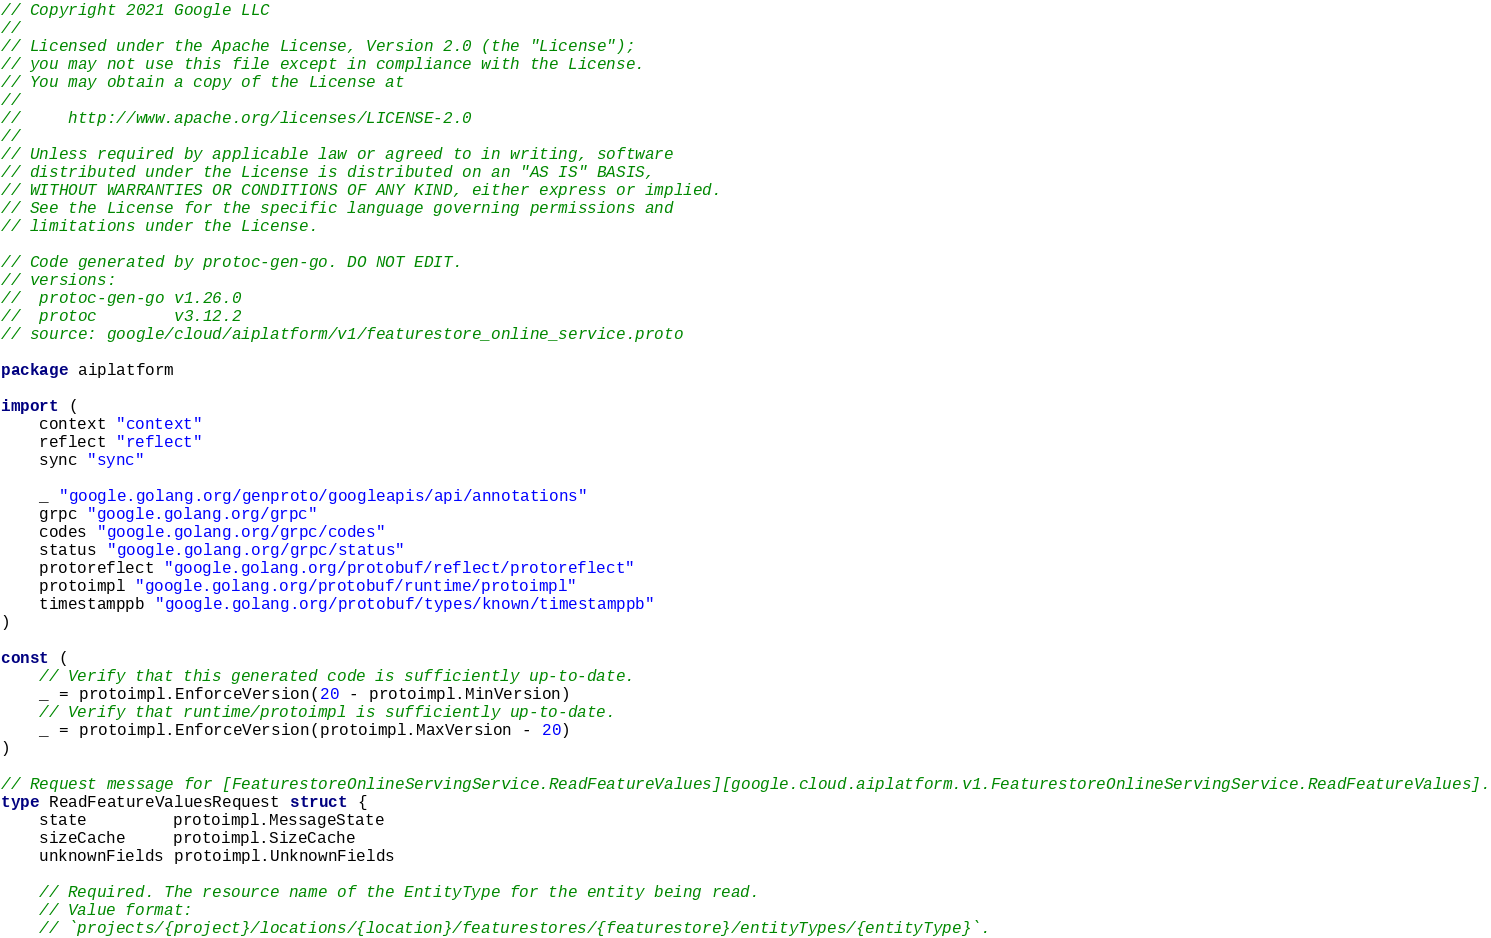Convert code to text. <code><loc_0><loc_0><loc_500><loc_500><_Go_>// Copyright 2021 Google LLC
//
// Licensed under the Apache License, Version 2.0 (the "License");
// you may not use this file except in compliance with the License.
// You may obtain a copy of the License at
//
//     http://www.apache.org/licenses/LICENSE-2.0
//
// Unless required by applicable law or agreed to in writing, software
// distributed under the License is distributed on an "AS IS" BASIS,
// WITHOUT WARRANTIES OR CONDITIONS OF ANY KIND, either express or implied.
// See the License for the specific language governing permissions and
// limitations under the License.

// Code generated by protoc-gen-go. DO NOT EDIT.
// versions:
// 	protoc-gen-go v1.26.0
// 	protoc        v3.12.2
// source: google/cloud/aiplatform/v1/featurestore_online_service.proto

package aiplatform

import (
	context "context"
	reflect "reflect"
	sync "sync"

	_ "google.golang.org/genproto/googleapis/api/annotations"
	grpc "google.golang.org/grpc"
	codes "google.golang.org/grpc/codes"
	status "google.golang.org/grpc/status"
	protoreflect "google.golang.org/protobuf/reflect/protoreflect"
	protoimpl "google.golang.org/protobuf/runtime/protoimpl"
	timestamppb "google.golang.org/protobuf/types/known/timestamppb"
)

const (
	// Verify that this generated code is sufficiently up-to-date.
	_ = protoimpl.EnforceVersion(20 - protoimpl.MinVersion)
	// Verify that runtime/protoimpl is sufficiently up-to-date.
	_ = protoimpl.EnforceVersion(protoimpl.MaxVersion - 20)
)

// Request message for [FeaturestoreOnlineServingService.ReadFeatureValues][google.cloud.aiplatform.v1.FeaturestoreOnlineServingService.ReadFeatureValues].
type ReadFeatureValuesRequest struct {
	state         protoimpl.MessageState
	sizeCache     protoimpl.SizeCache
	unknownFields protoimpl.UnknownFields

	// Required. The resource name of the EntityType for the entity being read.
	// Value format:
	// `projects/{project}/locations/{location}/featurestores/{featurestore}/entityTypes/{entityType}`.</code> 